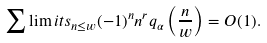<formula> <loc_0><loc_0><loc_500><loc_500>\sum \lim i t s _ { n \leq w } ( - 1 ) ^ { n } n ^ { r } q _ { \alpha } \left ( \frac { n } { w } \right ) = O ( 1 ) .</formula> 